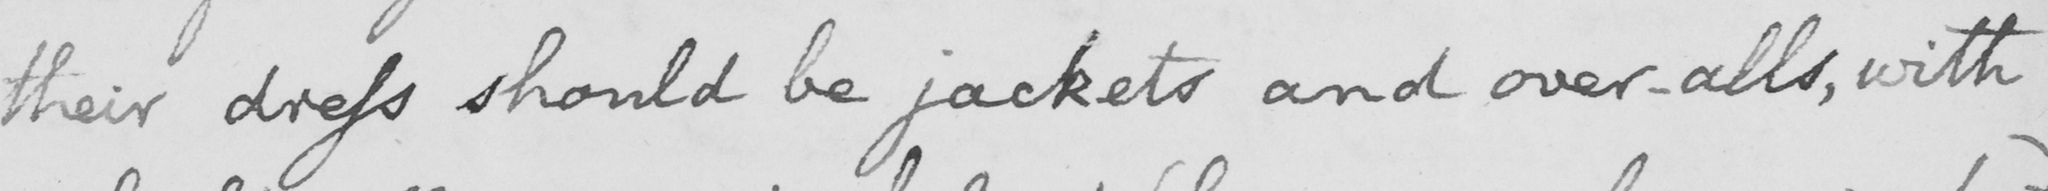Transcribe the text shown in this historical manuscript line. their dress should be jackets and over-alls , with 